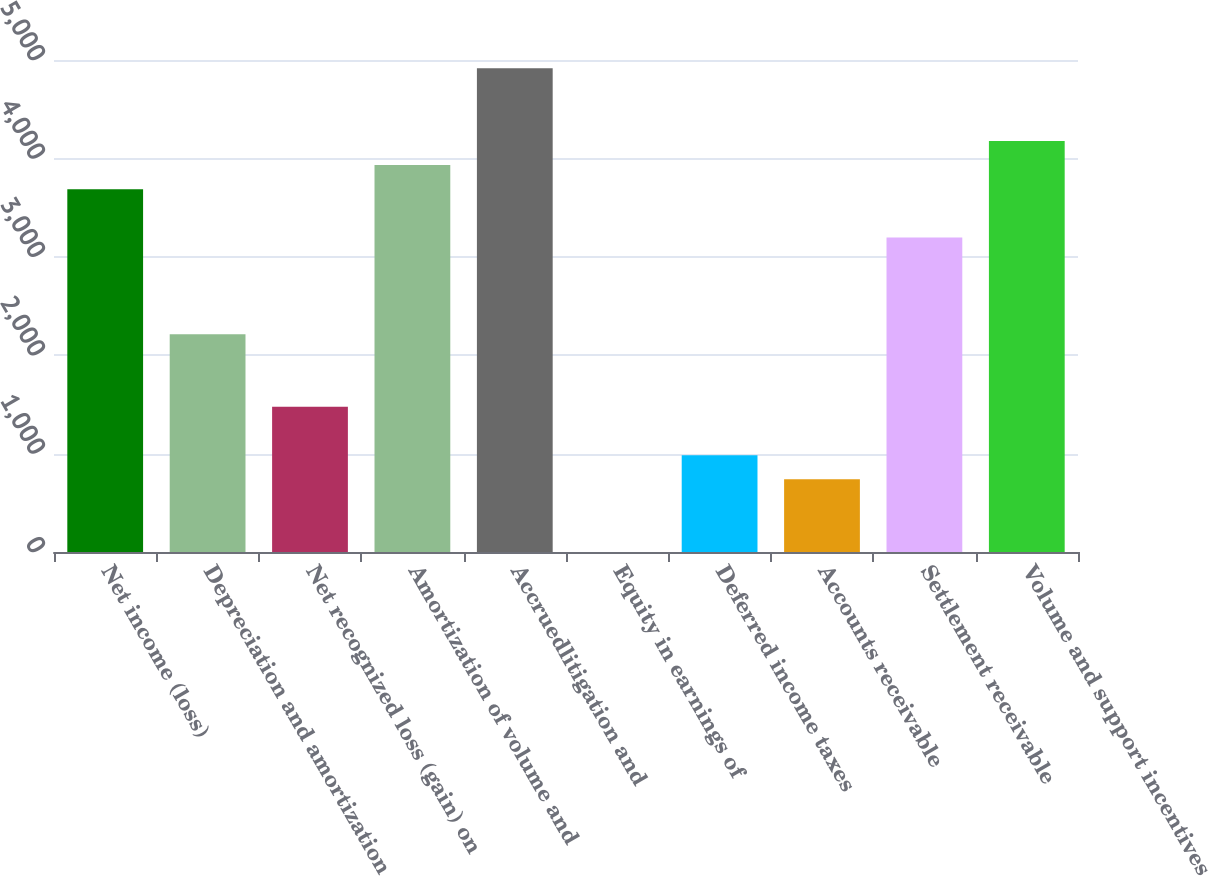<chart> <loc_0><loc_0><loc_500><loc_500><bar_chart><fcel>Net income (loss)<fcel>Depreciation and amortization<fcel>Net recognized loss (gain) on<fcel>Amortization of volume and<fcel>Accruedlitigation and<fcel>Equity in earnings of<fcel>Deferred income taxes<fcel>Accounts receivable<fcel>Settlement receivable<fcel>Volume and support incentives<nl><fcel>3686.5<fcel>2212.3<fcel>1475.2<fcel>3932.2<fcel>4915<fcel>1<fcel>983.8<fcel>738.1<fcel>3195.1<fcel>4177.9<nl></chart> 